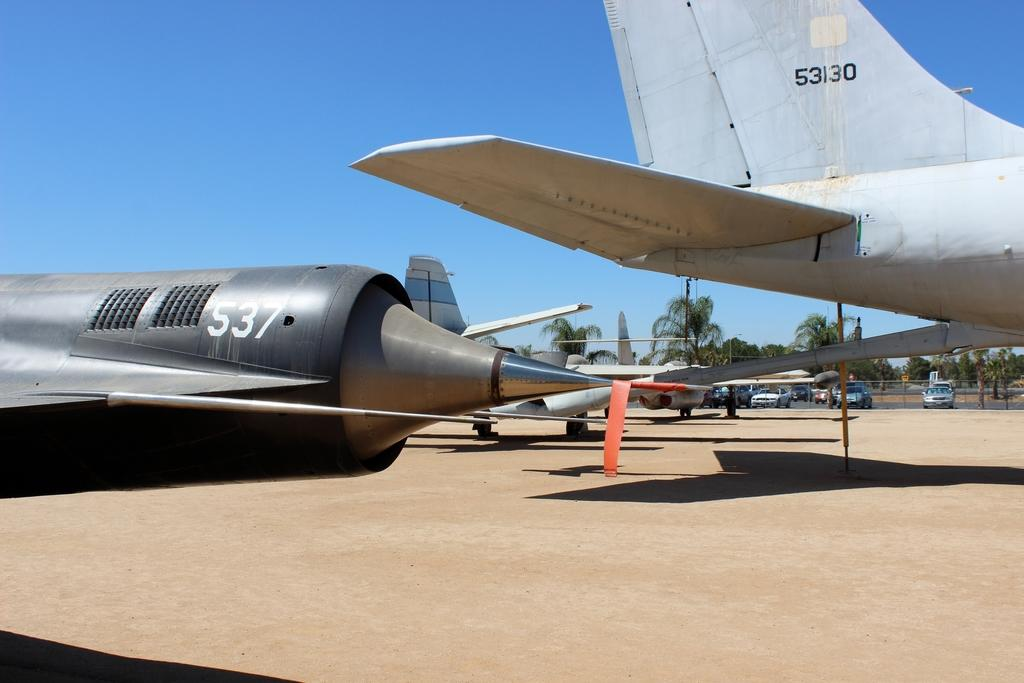<image>
Describe the image concisely. 53130 is painted on one of the planes sitting in this group 